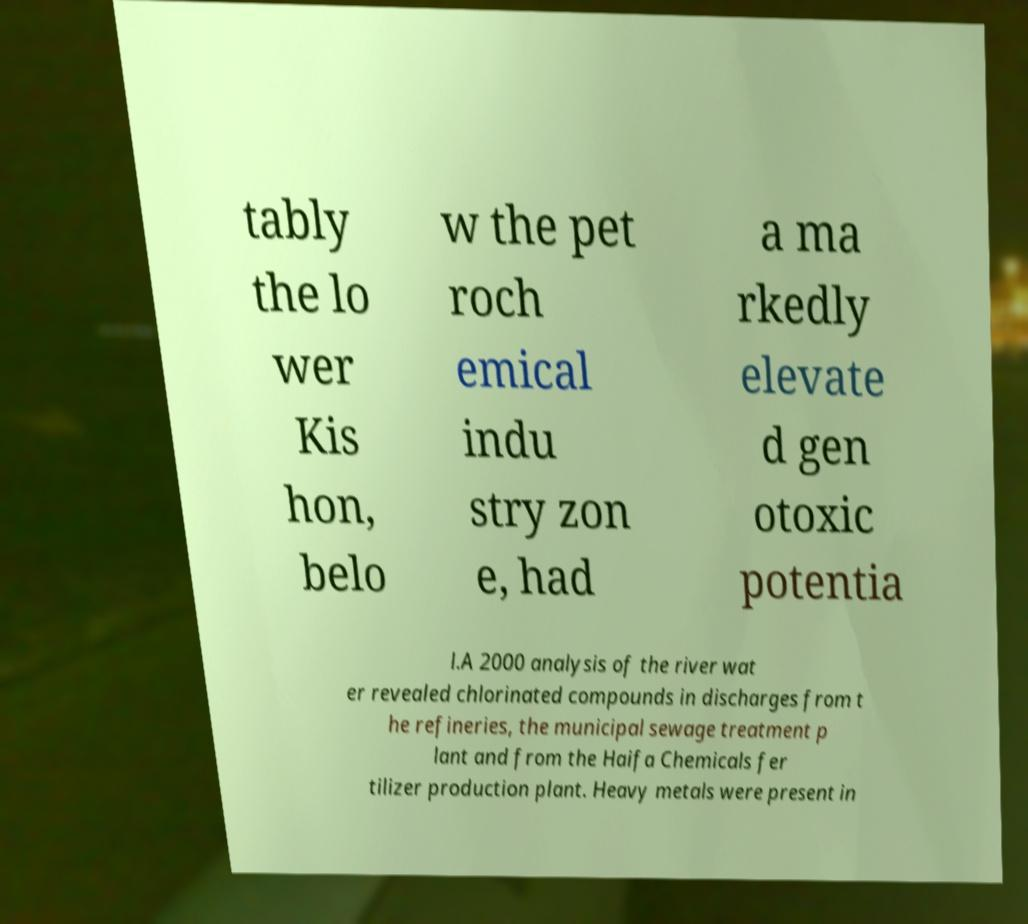There's text embedded in this image that I need extracted. Can you transcribe it verbatim? tably the lo wer Kis hon, belo w the pet roch emical indu stry zon e, had a ma rkedly elevate d gen otoxic potentia l.A 2000 analysis of the river wat er revealed chlorinated compounds in discharges from t he refineries, the municipal sewage treatment p lant and from the Haifa Chemicals fer tilizer production plant. Heavy metals were present in 